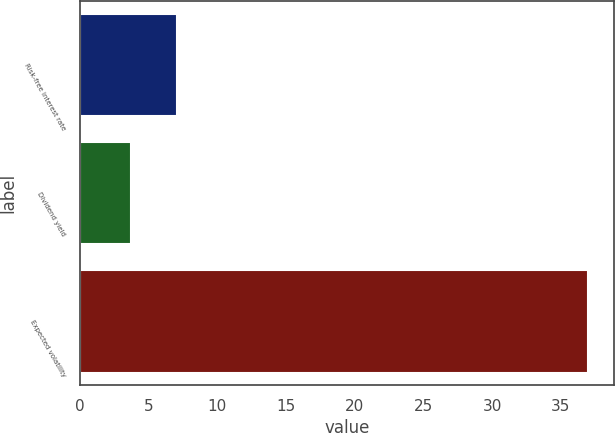<chart> <loc_0><loc_0><loc_500><loc_500><bar_chart><fcel>Risk-free interest rate<fcel>Dividend yield<fcel>Expected volatility<nl><fcel>7.07<fcel>3.74<fcel>37<nl></chart> 